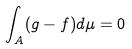<formula> <loc_0><loc_0><loc_500><loc_500>\int _ { A } ( g - f ) d \mu = 0</formula> 